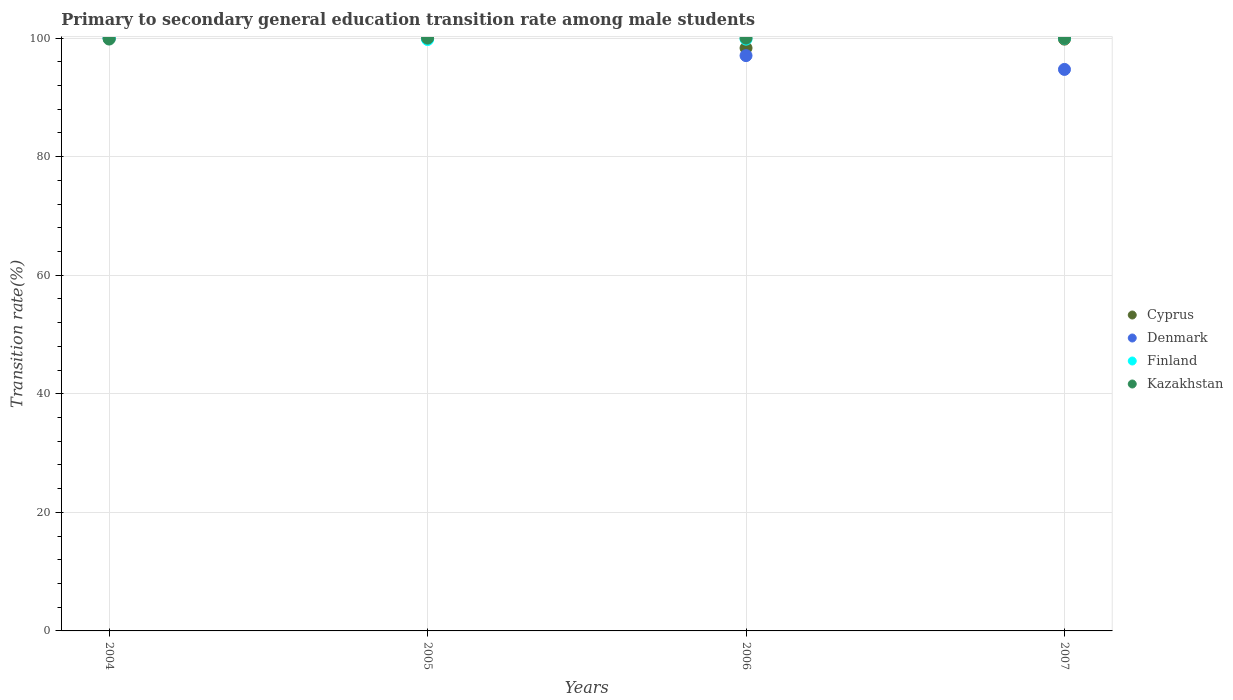How many different coloured dotlines are there?
Your response must be concise. 4. Is the number of dotlines equal to the number of legend labels?
Offer a terse response. Yes. What is the transition rate in Kazakhstan in 2006?
Offer a terse response. 100. Across all years, what is the maximum transition rate in Finland?
Your answer should be compact. 100. Across all years, what is the minimum transition rate in Denmark?
Your response must be concise. 94.72. What is the total transition rate in Cyprus in the graph?
Your response must be concise. 398.16. What is the difference between the transition rate in Finland in 2006 and that in 2007?
Provide a short and direct response. -0.17. What is the difference between the transition rate in Denmark in 2004 and the transition rate in Cyprus in 2005?
Keep it short and to the point. 0. What is the average transition rate in Denmark per year?
Provide a succinct answer. 97.94. In the year 2006, what is the difference between the transition rate in Kazakhstan and transition rate in Finland?
Your answer should be very brief. 0.17. Is the transition rate in Finland in 2006 less than that in 2007?
Ensure brevity in your answer.  Yes. What is the difference between the highest and the second highest transition rate in Kazakhstan?
Your response must be concise. 0. What is the difference between the highest and the lowest transition rate in Cyprus?
Keep it short and to the point. 1.67. In how many years, is the transition rate in Kazakhstan greater than the average transition rate in Kazakhstan taken over all years?
Your answer should be very brief. 3. Is the sum of the transition rate in Finland in 2004 and 2007 greater than the maximum transition rate in Kazakhstan across all years?
Provide a succinct answer. Yes. Does the transition rate in Cyprus monotonically increase over the years?
Ensure brevity in your answer.  No. Is the transition rate in Denmark strictly greater than the transition rate in Kazakhstan over the years?
Your response must be concise. No. Is the transition rate in Kazakhstan strictly less than the transition rate in Cyprus over the years?
Your answer should be very brief. No. How many dotlines are there?
Keep it short and to the point. 4. How many years are there in the graph?
Your answer should be compact. 4. Where does the legend appear in the graph?
Keep it short and to the point. Center right. How are the legend labels stacked?
Your response must be concise. Vertical. What is the title of the graph?
Keep it short and to the point. Primary to secondary general education transition rate among male students. Does "Uganda" appear as one of the legend labels in the graph?
Offer a very short reply. No. What is the label or title of the X-axis?
Your answer should be compact. Years. What is the label or title of the Y-axis?
Keep it short and to the point. Transition rate(%). What is the Transition rate(%) in Denmark in 2004?
Your answer should be very brief. 100. What is the Transition rate(%) of Kazakhstan in 2004?
Your answer should be compact. 99.84. What is the Transition rate(%) in Finland in 2005?
Your answer should be very brief. 99.77. What is the Transition rate(%) of Cyprus in 2006?
Give a very brief answer. 98.33. What is the Transition rate(%) in Denmark in 2006?
Your answer should be compact. 97.05. What is the Transition rate(%) in Finland in 2006?
Offer a terse response. 99.83. What is the Transition rate(%) in Kazakhstan in 2006?
Your answer should be compact. 100. What is the Transition rate(%) of Cyprus in 2007?
Make the answer very short. 99.83. What is the Transition rate(%) of Denmark in 2007?
Your answer should be compact. 94.72. What is the Transition rate(%) of Finland in 2007?
Keep it short and to the point. 100. What is the Transition rate(%) in Kazakhstan in 2007?
Provide a short and direct response. 100. Across all years, what is the maximum Transition rate(%) of Cyprus?
Keep it short and to the point. 100. Across all years, what is the minimum Transition rate(%) of Cyprus?
Your answer should be compact. 98.33. Across all years, what is the minimum Transition rate(%) of Denmark?
Offer a very short reply. 94.72. Across all years, what is the minimum Transition rate(%) of Finland?
Offer a terse response. 99.77. Across all years, what is the minimum Transition rate(%) of Kazakhstan?
Provide a short and direct response. 99.84. What is the total Transition rate(%) in Cyprus in the graph?
Provide a succinct answer. 398.16. What is the total Transition rate(%) in Denmark in the graph?
Keep it short and to the point. 391.78. What is the total Transition rate(%) in Finland in the graph?
Provide a short and direct response. 399.6. What is the total Transition rate(%) in Kazakhstan in the graph?
Provide a succinct answer. 399.84. What is the difference between the Transition rate(%) of Cyprus in 2004 and that in 2005?
Give a very brief answer. 0. What is the difference between the Transition rate(%) of Finland in 2004 and that in 2005?
Offer a very short reply. 0.23. What is the difference between the Transition rate(%) in Kazakhstan in 2004 and that in 2005?
Give a very brief answer. -0.16. What is the difference between the Transition rate(%) of Cyprus in 2004 and that in 2006?
Give a very brief answer. 1.67. What is the difference between the Transition rate(%) of Denmark in 2004 and that in 2006?
Ensure brevity in your answer.  2.95. What is the difference between the Transition rate(%) in Finland in 2004 and that in 2006?
Ensure brevity in your answer.  0.17. What is the difference between the Transition rate(%) in Kazakhstan in 2004 and that in 2006?
Ensure brevity in your answer.  -0.16. What is the difference between the Transition rate(%) of Cyprus in 2004 and that in 2007?
Ensure brevity in your answer.  0.17. What is the difference between the Transition rate(%) of Denmark in 2004 and that in 2007?
Offer a very short reply. 5.28. What is the difference between the Transition rate(%) of Finland in 2004 and that in 2007?
Offer a terse response. 0. What is the difference between the Transition rate(%) of Kazakhstan in 2004 and that in 2007?
Keep it short and to the point. -0.16. What is the difference between the Transition rate(%) of Cyprus in 2005 and that in 2006?
Keep it short and to the point. 1.67. What is the difference between the Transition rate(%) of Denmark in 2005 and that in 2006?
Provide a short and direct response. 2.95. What is the difference between the Transition rate(%) in Finland in 2005 and that in 2006?
Provide a short and direct response. -0.07. What is the difference between the Transition rate(%) of Cyprus in 2005 and that in 2007?
Offer a terse response. 0.17. What is the difference between the Transition rate(%) of Denmark in 2005 and that in 2007?
Offer a very short reply. 5.28. What is the difference between the Transition rate(%) in Finland in 2005 and that in 2007?
Your answer should be very brief. -0.23. What is the difference between the Transition rate(%) in Cyprus in 2006 and that in 2007?
Your answer should be very brief. -1.5. What is the difference between the Transition rate(%) of Denmark in 2006 and that in 2007?
Keep it short and to the point. 2.33. What is the difference between the Transition rate(%) of Finland in 2006 and that in 2007?
Provide a short and direct response. -0.17. What is the difference between the Transition rate(%) of Cyprus in 2004 and the Transition rate(%) of Denmark in 2005?
Ensure brevity in your answer.  0. What is the difference between the Transition rate(%) in Cyprus in 2004 and the Transition rate(%) in Finland in 2005?
Offer a very short reply. 0.23. What is the difference between the Transition rate(%) in Denmark in 2004 and the Transition rate(%) in Finland in 2005?
Keep it short and to the point. 0.23. What is the difference between the Transition rate(%) of Denmark in 2004 and the Transition rate(%) of Kazakhstan in 2005?
Give a very brief answer. 0. What is the difference between the Transition rate(%) in Cyprus in 2004 and the Transition rate(%) in Denmark in 2006?
Offer a very short reply. 2.95. What is the difference between the Transition rate(%) of Cyprus in 2004 and the Transition rate(%) of Finland in 2006?
Provide a succinct answer. 0.17. What is the difference between the Transition rate(%) of Cyprus in 2004 and the Transition rate(%) of Kazakhstan in 2006?
Your answer should be very brief. 0. What is the difference between the Transition rate(%) in Denmark in 2004 and the Transition rate(%) in Finland in 2006?
Your answer should be very brief. 0.17. What is the difference between the Transition rate(%) of Finland in 2004 and the Transition rate(%) of Kazakhstan in 2006?
Your response must be concise. 0. What is the difference between the Transition rate(%) in Cyprus in 2004 and the Transition rate(%) in Denmark in 2007?
Make the answer very short. 5.28. What is the difference between the Transition rate(%) in Cyprus in 2005 and the Transition rate(%) in Denmark in 2006?
Provide a succinct answer. 2.95. What is the difference between the Transition rate(%) of Cyprus in 2005 and the Transition rate(%) of Finland in 2006?
Your answer should be compact. 0.17. What is the difference between the Transition rate(%) in Cyprus in 2005 and the Transition rate(%) in Kazakhstan in 2006?
Offer a terse response. 0. What is the difference between the Transition rate(%) of Denmark in 2005 and the Transition rate(%) of Finland in 2006?
Make the answer very short. 0.17. What is the difference between the Transition rate(%) in Finland in 2005 and the Transition rate(%) in Kazakhstan in 2006?
Offer a very short reply. -0.23. What is the difference between the Transition rate(%) in Cyprus in 2005 and the Transition rate(%) in Denmark in 2007?
Your answer should be compact. 5.28. What is the difference between the Transition rate(%) of Cyprus in 2005 and the Transition rate(%) of Finland in 2007?
Offer a terse response. 0. What is the difference between the Transition rate(%) in Cyprus in 2005 and the Transition rate(%) in Kazakhstan in 2007?
Your response must be concise. 0. What is the difference between the Transition rate(%) of Denmark in 2005 and the Transition rate(%) of Finland in 2007?
Provide a short and direct response. 0. What is the difference between the Transition rate(%) of Denmark in 2005 and the Transition rate(%) of Kazakhstan in 2007?
Offer a very short reply. 0. What is the difference between the Transition rate(%) in Finland in 2005 and the Transition rate(%) in Kazakhstan in 2007?
Your response must be concise. -0.23. What is the difference between the Transition rate(%) in Cyprus in 2006 and the Transition rate(%) in Denmark in 2007?
Keep it short and to the point. 3.61. What is the difference between the Transition rate(%) in Cyprus in 2006 and the Transition rate(%) in Finland in 2007?
Offer a terse response. -1.67. What is the difference between the Transition rate(%) in Cyprus in 2006 and the Transition rate(%) in Kazakhstan in 2007?
Offer a terse response. -1.67. What is the difference between the Transition rate(%) of Denmark in 2006 and the Transition rate(%) of Finland in 2007?
Ensure brevity in your answer.  -2.95. What is the difference between the Transition rate(%) in Denmark in 2006 and the Transition rate(%) in Kazakhstan in 2007?
Make the answer very short. -2.95. What is the difference between the Transition rate(%) in Finland in 2006 and the Transition rate(%) in Kazakhstan in 2007?
Provide a short and direct response. -0.17. What is the average Transition rate(%) of Cyprus per year?
Give a very brief answer. 99.54. What is the average Transition rate(%) of Denmark per year?
Ensure brevity in your answer.  97.94. What is the average Transition rate(%) of Finland per year?
Your answer should be compact. 99.9. What is the average Transition rate(%) of Kazakhstan per year?
Offer a very short reply. 99.96. In the year 2004, what is the difference between the Transition rate(%) of Cyprus and Transition rate(%) of Denmark?
Your answer should be compact. 0. In the year 2004, what is the difference between the Transition rate(%) of Cyprus and Transition rate(%) of Finland?
Make the answer very short. 0. In the year 2004, what is the difference between the Transition rate(%) of Cyprus and Transition rate(%) of Kazakhstan?
Provide a succinct answer. 0.16. In the year 2004, what is the difference between the Transition rate(%) of Denmark and Transition rate(%) of Finland?
Offer a terse response. 0. In the year 2004, what is the difference between the Transition rate(%) of Denmark and Transition rate(%) of Kazakhstan?
Make the answer very short. 0.16. In the year 2004, what is the difference between the Transition rate(%) of Finland and Transition rate(%) of Kazakhstan?
Provide a succinct answer. 0.16. In the year 2005, what is the difference between the Transition rate(%) in Cyprus and Transition rate(%) in Finland?
Provide a short and direct response. 0.23. In the year 2005, what is the difference between the Transition rate(%) in Cyprus and Transition rate(%) in Kazakhstan?
Give a very brief answer. 0. In the year 2005, what is the difference between the Transition rate(%) of Denmark and Transition rate(%) of Finland?
Make the answer very short. 0.23. In the year 2005, what is the difference between the Transition rate(%) of Finland and Transition rate(%) of Kazakhstan?
Provide a succinct answer. -0.23. In the year 2006, what is the difference between the Transition rate(%) in Cyprus and Transition rate(%) in Denmark?
Make the answer very short. 1.28. In the year 2006, what is the difference between the Transition rate(%) in Cyprus and Transition rate(%) in Finland?
Provide a succinct answer. -1.5. In the year 2006, what is the difference between the Transition rate(%) of Cyprus and Transition rate(%) of Kazakhstan?
Provide a succinct answer. -1.67. In the year 2006, what is the difference between the Transition rate(%) of Denmark and Transition rate(%) of Finland?
Offer a terse response. -2.78. In the year 2006, what is the difference between the Transition rate(%) in Denmark and Transition rate(%) in Kazakhstan?
Keep it short and to the point. -2.95. In the year 2006, what is the difference between the Transition rate(%) of Finland and Transition rate(%) of Kazakhstan?
Provide a short and direct response. -0.17. In the year 2007, what is the difference between the Transition rate(%) in Cyprus and Transition rate(%) in Denmark?
Provide a short and direct response. 5.11. In the year 2007, what is the difference between the Transition rate(%) of Cyprus and Transition rate(%) of Finland?
Your response must be concise. -0.17. In the year 2007, what is the difference between the Transition rate(%) of Cyprus and Transition rate(%) of Kazakhstan?
Your answer should be compact. -0.17. In the year 2007, what is the difference between the Transition rate(%) of Denmark and Transition rate(%) of Finland?
Offer a very short reply. -5.28. In the year 2007, what is the difference between the Transition rate(%) of Denmark and Transition rate(%) of Kazakhstan?
Your response must be concise. -5.28. What is the ratio of the Transition rate(%) of Finland in 2004 to that in 2005?
Keep it short and to the point. 1. What is the ratio of the Transition rate(%) in Cyprus in 2004 to that in 2006?
Your response must be concise. 1.02. What is the ratio of the Transition rate(%) in Denmark in 2004 to that in 2006?
Your answer should be compact. 1.03. What is the ratio of the Transition rate(%) of Kazakhstan in 2004 to that in 2006?
Give a very brief answer. 1. What is the ratio of the Transition rate(%) in Cyprus in 2004 to that in 2007?
Offer a terse response. 1. What is the ratio of the Transition rate(%) in Denmark in 2004 to that in 2007?
Offer a terse response. 1.06. What is the ratio of the Transition rate(%) in Finland in 2004 to that in 2007?
Provide a short and direct response. 1. What is the ratio of the Transition rate(%) in Denmark in 2005 to that in 2006?
Give a very brief answer. 1.03. What is the ratio of the Transition rate(%) in Kazakhstan in 2005 to that in 2006?
Your answer should be compact. 1. What is the ratio of the Transition rate(%) of Cyprus in 2005 to that in 2007?
Make the answer very short. 1. What is the ratio of the Transition rate(%) of Denmark in 2005 to that in 2007?
Offer a very short reply. 1.06. What is the ratio of the Transition rate(%) in Cyprus in 2006 to that in 2007?
Offer a very short reply. 0.98. What is the ratio of the Transition rate(%) of Denmark in 2006 to that in 2007?
Give a very brief answer. 1.02. What is the ratio of the Transition rate(%) in Kazakhstan in 2006 to that in 2007?
Ensure brevity in your answer.  1. What is the difference between the highest and the second highest Transition rate(%) of Finland?
Offer a very short reply. 0. What is the difference between the highest and the second highest Transition rate(%) in Kazakhstan?
Keep it short and to the point. 0. What is the difference between the highest and the lowest Transition rate(%) of Cyprus?
Give a very brief answer. 1.67. What is the difference between the highest and the lowest Transition rate(%) in Denmark?
Keep it short and to the point. 5.28. What is the difference between the highest and the lowest Transition rate(%) in Finland?
Offer a very short reply. 0.23. What is the difference between the highest and the lowest Transition rate(%) in Kazakhstan?
Offer a terse response. 0.16. 